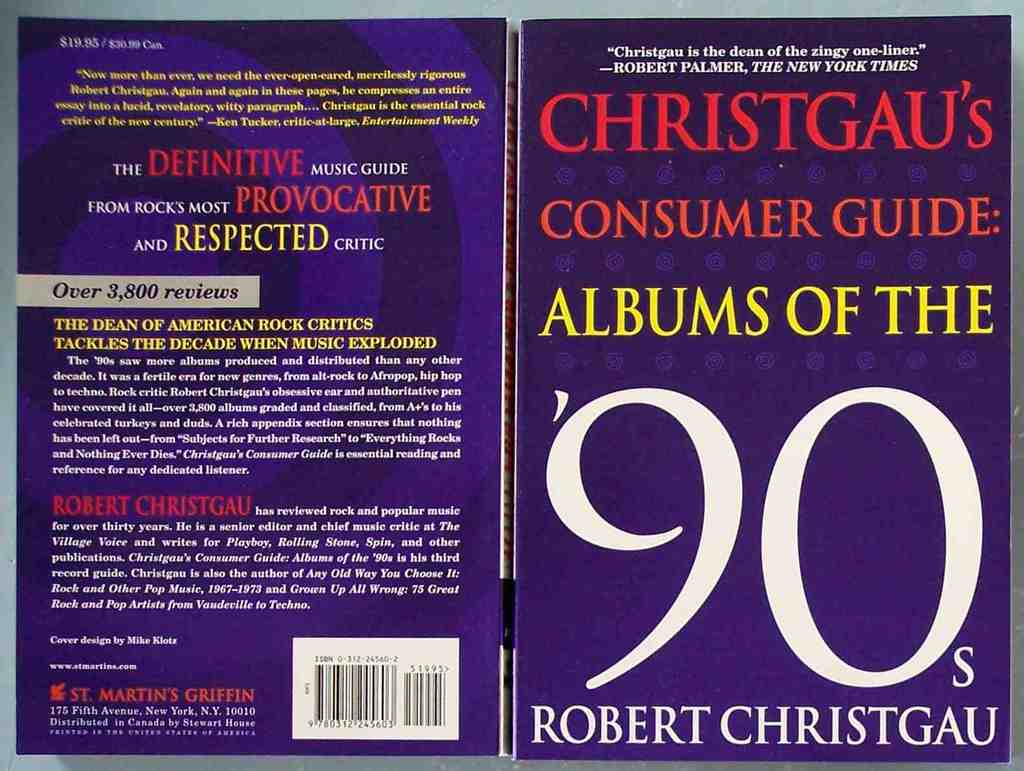What do you think is going on in this snapshot? The image presents both the front and back covers of 'Consumer Guide: Albums of the 90s' by Robert Christgau. Notably, the front cover, in an alluring purple hue with yellow typography, signals the vibrant and exciting era of 90s music it discusses. The back cover offers insights into the book’s structure, boasting over 3,800 meticulous and informative reviews, reflecting Christgau's reputation as a critical authority in music journalism. The quotes by notable figures like Ken Tucker and Robert Palmer not only underscore the author's respected status but also hint at the depth and punchiness of the reviews contained within, making it a valuable resource for understanding the musical landscape of the 1990s. 